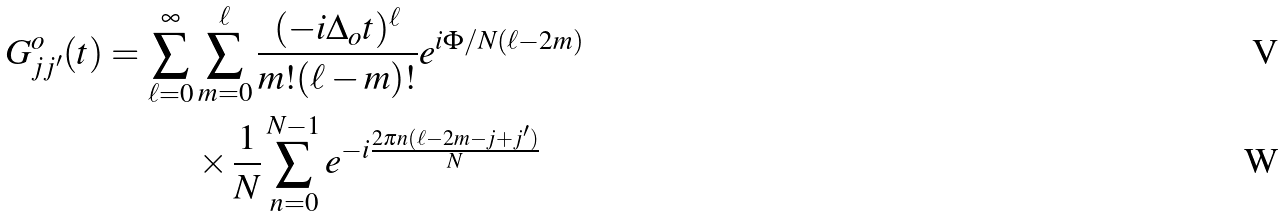Convert formula to latex. <formula><loc_0><loc_0><loc_500><loc_500>G ^ { o } _ { j j ^ { \prime } } ( t ) = \sum _ { \ell = 0 } ^ { \infty } & \sum _ { m = 0 } ^ { \ell } \frac { ( - i \Delta _ { o } t ) ^ { \ell } } { m ! ( \ell - m ) ! } e ^ { i \Phi / N ( \ell - 2 m ) } \\ & \times \frac { 1 } { N } \sum _ { n = 0 } ^ { N - 1 } e ^ { - i \frac { 2 \pi n ( \ell - 2 m - j + j ^ { \prime } ) } { N } } \</formula> 